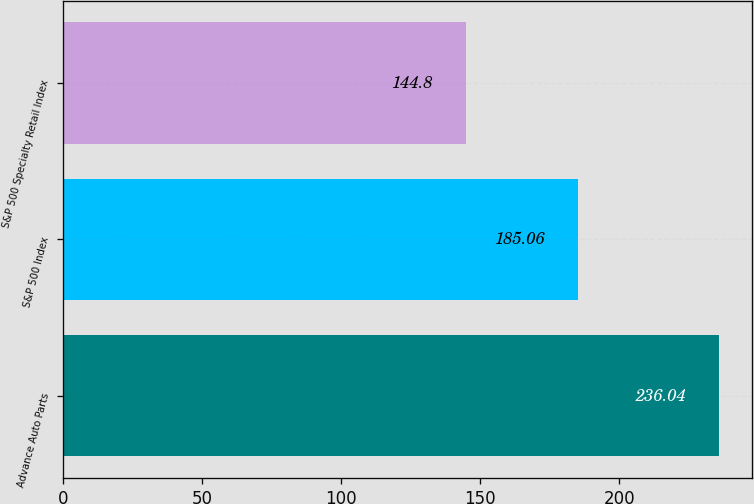Convert chart. <chart><loc_0><loc_0><loc_500><loc_500><bar_chart><fcel>Advance Auto Parts<fcel>S&P 500 Index<fcel>S&P 500 Specialty Retail Index<nl><fcel>236.04<fcel>185.06<fcel>144.8<nl></chart> 